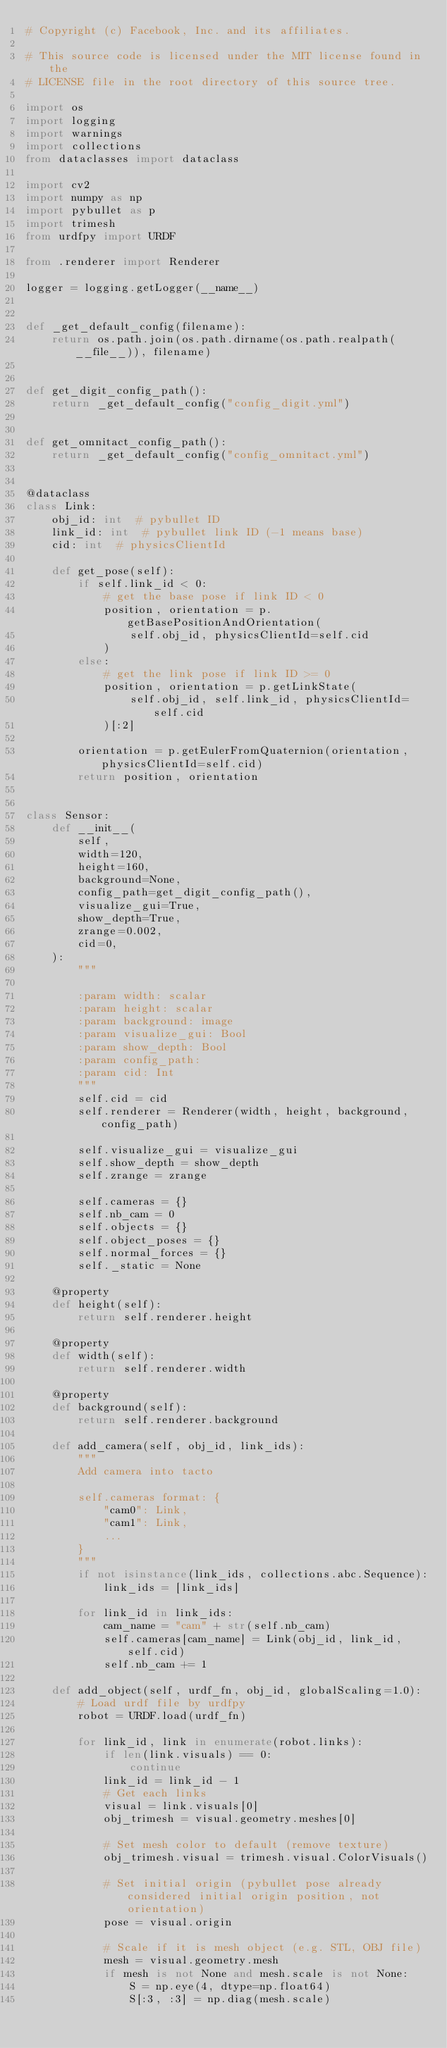Convert code to text. <code><loc_0><loc_0><loc_500><loc_500><_Python_># Copyright (c) Facebook, Inc. and its affiliates.

# This source code is licensed under the MIT license found in the
# LICENSE file in the root directory of this source tree.

import os
import logging
import warnings
import collections
from dataclasses import dataclass

import cv2
import numpy as np
import pybullet as p
import trimesh
from urdfpy import URDF

from .renderer import Renderer

logger = logging.getLogger(__name__)


def _get_default_config(filename):
    return os.path.join(os.path.dirname(os.path.realpath(__file__)), filename)


def get_digit_config_path():
    return _get_default_config("config_digit.yml")


def get_omnitact_config_path():
    return _get_default_config("config_omnitact.yml")


@dataclass
class Link:
    obj_id: int  # pybullet ID
    link_id: int  # pybullet link ID (-1 means base)
    cid: int  # physicsClientId

    def get_pose(self):
        if self.link_id < 0:
            # get the base pose if link ID < 0
            position, orientation = p.getBasePositionAndOrientation(
                self.obj_id, physicsClientId=self.cid
            )
        else:
            # get the link pose if link ID >= 0
            position, orientation = p.getLinkState(
                self.obj_id, self.link_id, physicsClientId=self.cid
            )[:2]

        orientation = p.getEulerFromQuaternion(orientation, physicsClientId=self.cid)
        return position, orientation


class Sensor:
    def __init__(
        self,
        width=120,
        height=160,
        background=None,
        config_path=get_digit_config_path(),
        visualize_gui=True,
        show_depth=True,
        zrange=0.002,
        cid=0,
    ):
        """

        :param width: scalar
        :param height: scalar
        :param background: image
        :param visualize_gui: Bool
        :param show_depth: Bool
        :param config_path:
        :param cid: Int
        """
        self.cid = cid
        self.renderer = Renderer(width, height, background, config_path)

        self.visualize_gui = visualize_gui
        self.show_depth = show_depth
        self.zrange = zrange

        self.cameras = {}
        self.nb_cam = 0
        self.objects = {}
        self.object_poses = {}
        self.normal_forces = {}
        self._static = None

    @property
    def height(self):
        return self.renderer.height

    @property
    def width(self):
        return self.renderer.width

    @property
    def background(self):
        return self.renderer.background

    def add_camera(self, obj_id, link_ids):
        """
        Add camera into tacto

        self.cameras format: {
            "cam0": Link,
            "cam1": Link,
            ...
        }
        """
        if not isinstance(link_ids, collections.abc.Sequence):
            link_ids = [link_ids]

        for link_id in link_ids:
            cam_name = "cam" + str(self.nb_cam)
            self.cameras[cam_name] = Link(obj_id, link_id, self.cid)
            self.nb_cam += 1

    def add_object(self, urdf_fn, obj_id, globalScaling=1.0):
        # Load urdf file by urdfpy
        robot = URDF.load(urdf_fn)

        for link_id, link in enumerate(robot.links):
            if len(link.visuals) == 0:
                continue
            link_id = link_id - 1
            # Get each links
            visual = link.visuals[0]
            obj_trimesh = visual.geometry.meshes[0]

            # Set mesh color to default (remove texture)
            obj_trimesh.visual = trimesh.visual.ColorVisuals()

            # Set initial origin (pybullet pose already considered initial origin position, not orientation)
            pose = visual.origin

            # Scale if it is mesh object (e.g. STL, OBJ file)
            mesh = visual.geometry.mesh
            if mesh is not None and mesh.scale is not None:
                S = np.eye(4, dtype=np.float64)
                S[:3, :3] = np.diag(mesh.scale)</code> 